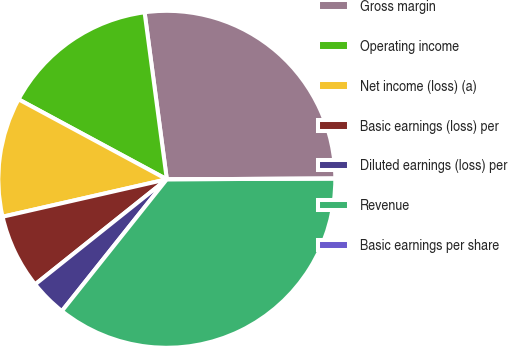Convert chart to OTSL. <chart><loc_0><loc_0><loc_500><loc_500><pie_chart><fcel>Gross margin<fcel>Operating income<fcel>Net income (loss) (a)<fcel>Basic earnings (loss) per<fcel>Diluted earnings (loss) per<fcel>Revenue<fcel>Basic earnings per share<nl><fcel>27.04%<fcel>15.02%<fcel>11.44%<fcel>7.15%<fcel>3.58%<fcel>35.77%<fcel>0.0%<nl></chart> 